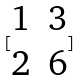<formula> <loc_0><loc_0><loc_500><loc_500>[ \begin{matrix} 1 & 3 \\ 2 & 6 \end{matrix} ]</formula> 